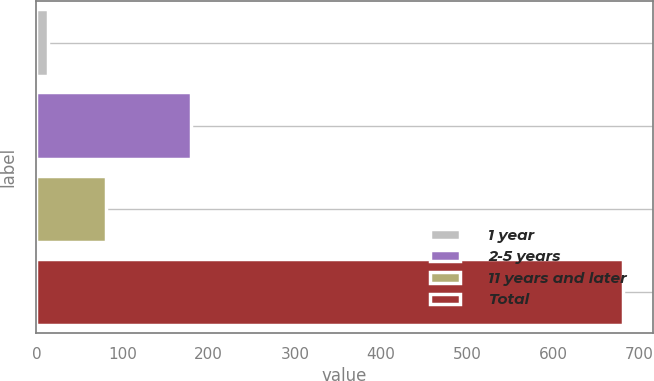Convert chart. <chart><loc_0><loc_0><loc_500><loc_500><bar_chart><fcel>1 year<fcel>2-5 years<fcel>11 years and later<fcel>Total<nl><fcel>14<fcel>180<fcel>80.7<fcel>681<nl></chart> 